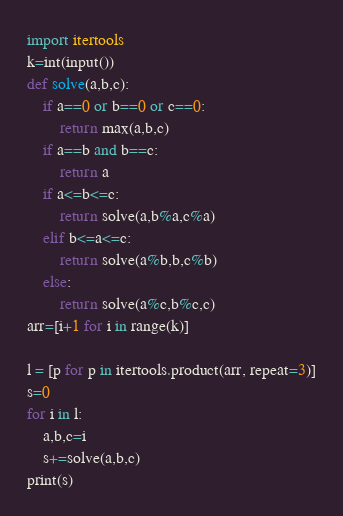Convert code to text. <code><loc_0><loc_0><loc_500><loc_500><_Python_>import itertools
k=int(input())
def solve(a,b,c):
	if a==0 or b==0 or c==0:
		return max(a,b,c)
	if a==b and b==c:
		return a
	if a<=b<=c:
		return solve(a,b%a,c%a)
	elif b<=a<=c:
		return solve(a%b,b,c%b)
	else:
		return solve(a%c,b%c,c)
arr=[i+1 for i in range(k)]

l = [p for p in itertools.product(arr, repeat=3)]
s=0
for i in l:
	a,b,c=i
	s+=solve(a,b,c)
print(s)</code> 